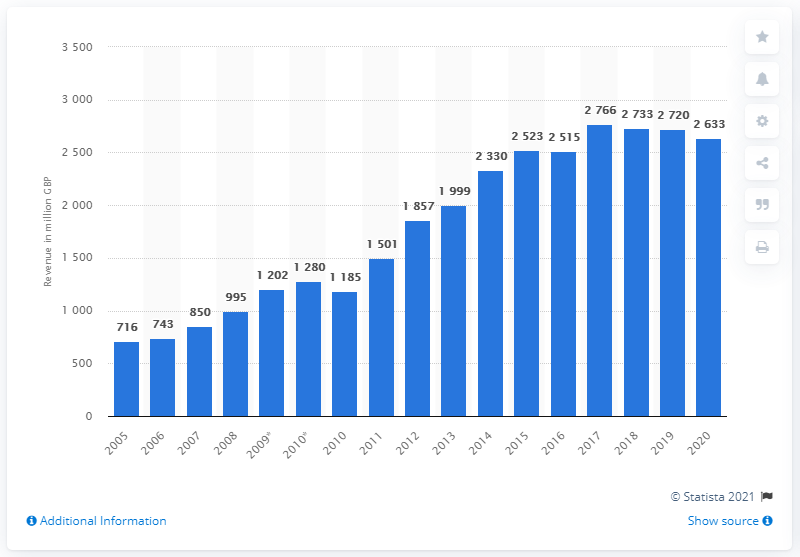Indicate a few pertinent items in this graphic. Burberry's worldwide revenue in 2020 was £2633 million. 